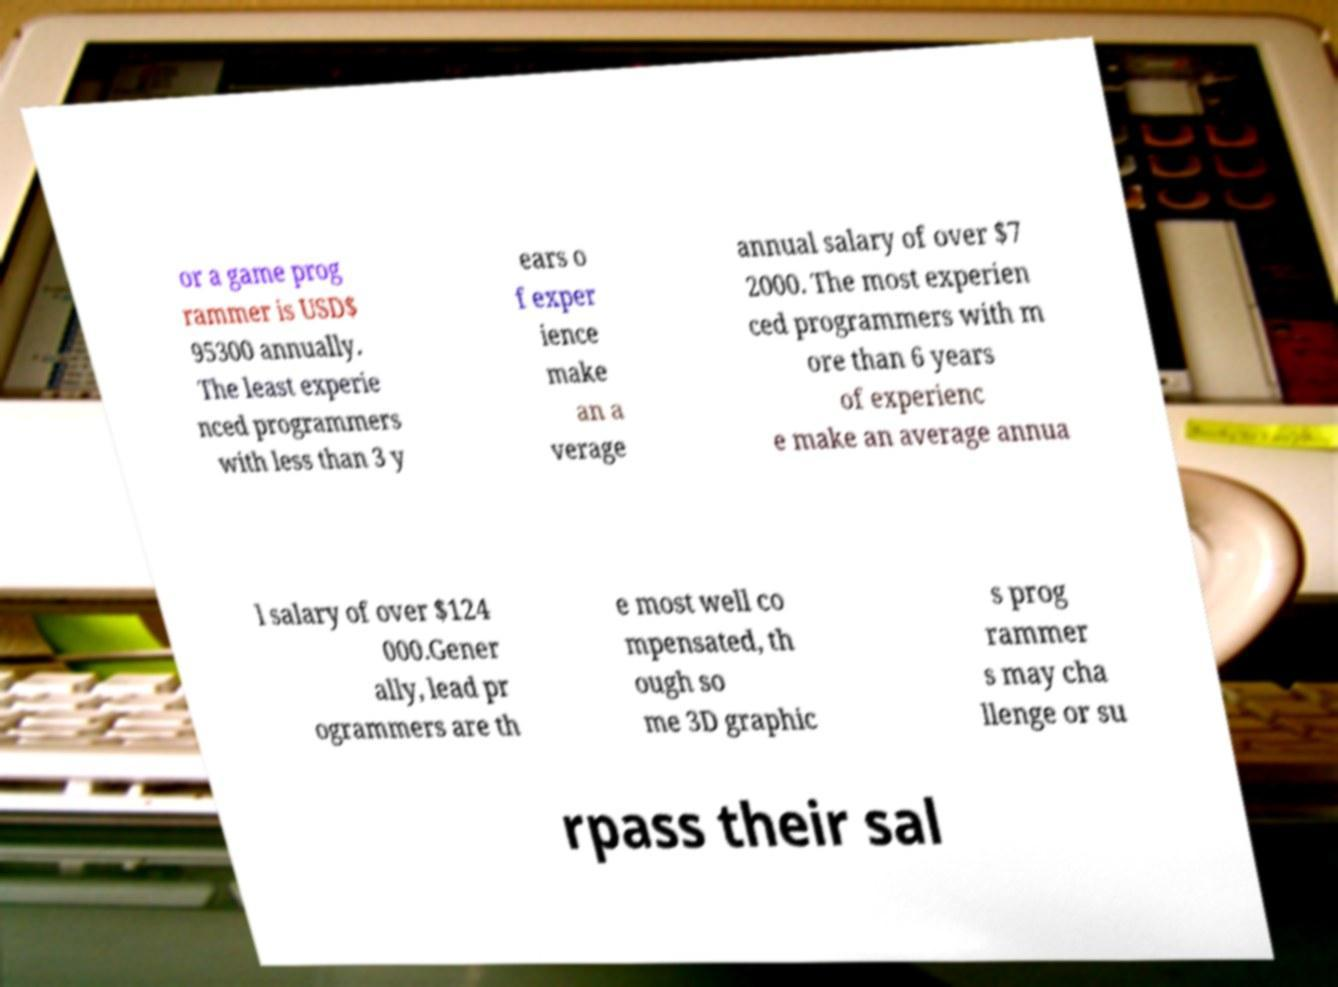Could you extract and type out the text from this image? or a game prog rammer is USD$ 95300 annually. The least experie nced programmers with less than 3 y ears o f exper ience make an a verage annual salary of over $7 2000. The most experien ced programmers with m ore than 6 years of experienc e make an average annua l salary of over $124 000.Gener ally, lead pr ogrammers are th e most well co mpensated, th ough so me 3D graphic s prog rammer s may cha llenge or su rpass their sal 